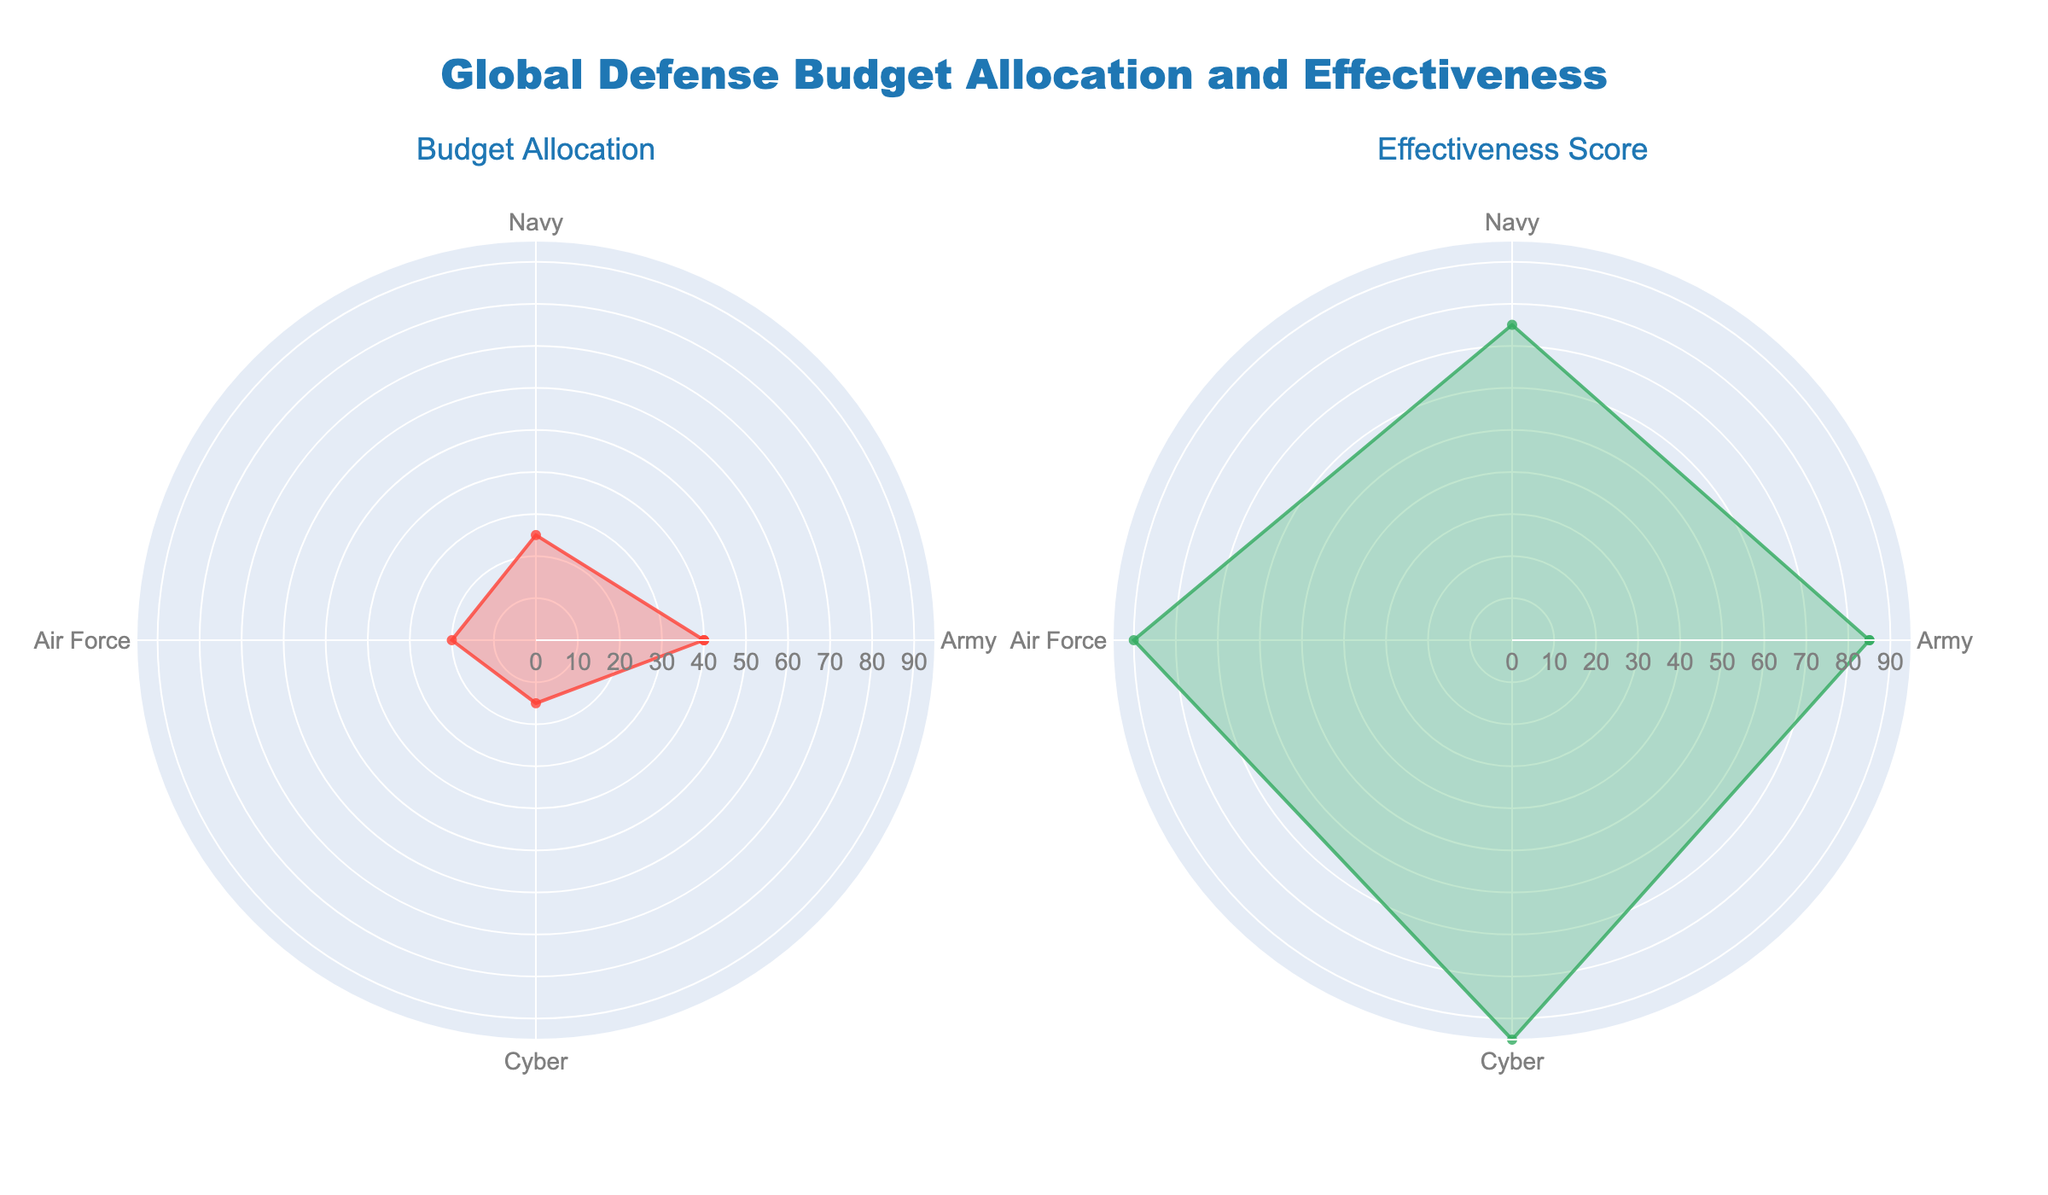What's the title of the figure? The title is prominently displayed at the top center of the figure. It reads "Global Defense Budget Allocation and Effectiveness".
Answer: Global Defense Budget Allocation and Effectiveness Which branch has the lowest budget allocation? The radial plot for budget allocation shows that the Cyber branch has the smallest area, indicating the lowest allocation percentage.
Answer: Cyber Which branch scores the highest in effectiveness? The radar chart for effectiveness scores shows that the Cyber branch reaches the highest point on the radial axis.
Answer: Cyber What is the budget allocation percentage for the Air Force? By examining the radial plot for budget allocation, the Air Force percentage extends to the 20% mark.
Answer: 20% How much higher is the effectiveness score of the Cyber branch compared to the Army? The effectiveness score for Cyber is 95, and for the Army, it is 85. The difference is calculated as 95 - 85.
Answer: 10 Which branch shows the most significant gap between budget allocation and effectiveness score? Observing both subplots, Cyber shows a significant gap, with 15% allocation and 95 effectiveness.
Answer: Cyber What's the average budget allocation among all branches? Sum the percentages (40+25+20+15 = 100) and divide by 4 (number of branches). The average allocation is 100/4.
Answer: 25% In which subplot does the Army branch have the highest relative value? Comparing both plots, the Army branch visual representation in the budget allocation plot (40%) is higher than in the effectiveness plot (85).
Answer: Budget Allocation Which branch's effectiveness is closest to its budget allocation? The difference between budget and effectiveness for each branch is observed. The Navy has a 25% allocation and 75 effectiveness, yielding the smallest difference (50).
Answer: Navy 